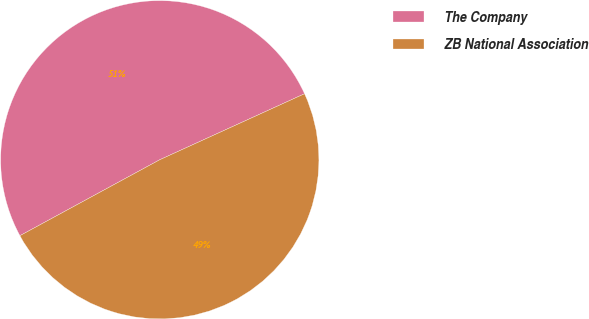<chart> <loc_0><loc_0><loc_500><loc_500><pie_chart><fcel>The Company<fcel>ZB National Association<nl><fcel>51.11%<fcel>48.89%<nl></chart> 